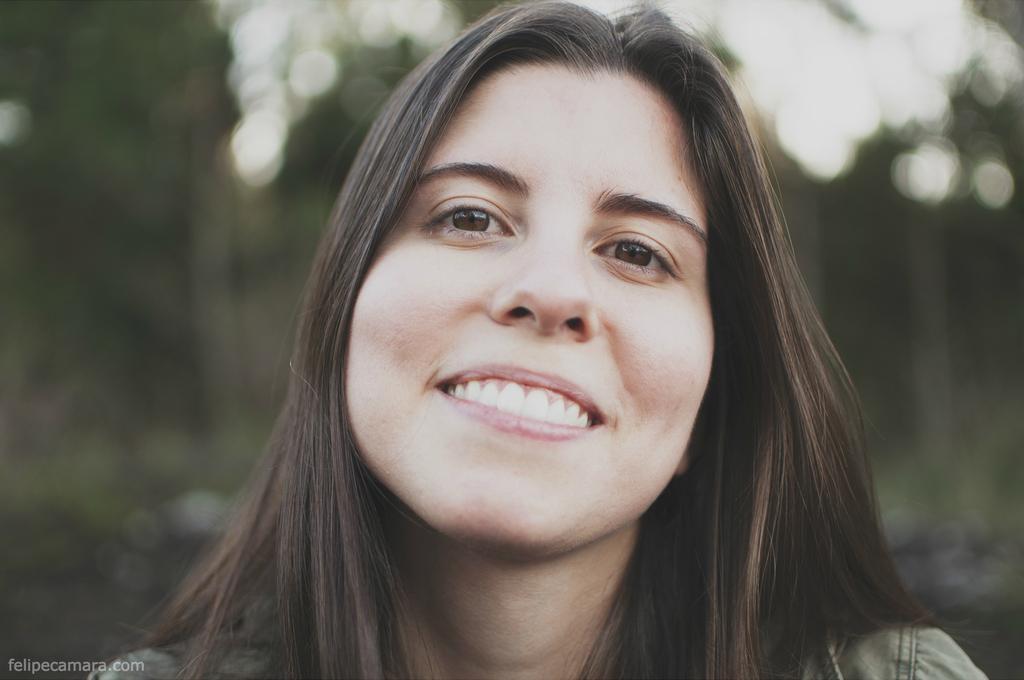Can you describe this image briefly? In this image I see a woman who is smiling and I see a watermark over here and I see that it is blurred in the background. 